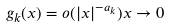<formula> <loc_0><loc_0><loc_500><loc_500>g _ { k } ( x ) = o ( | x | ^ { - a _ { k } } ) x \to 0</formula> 